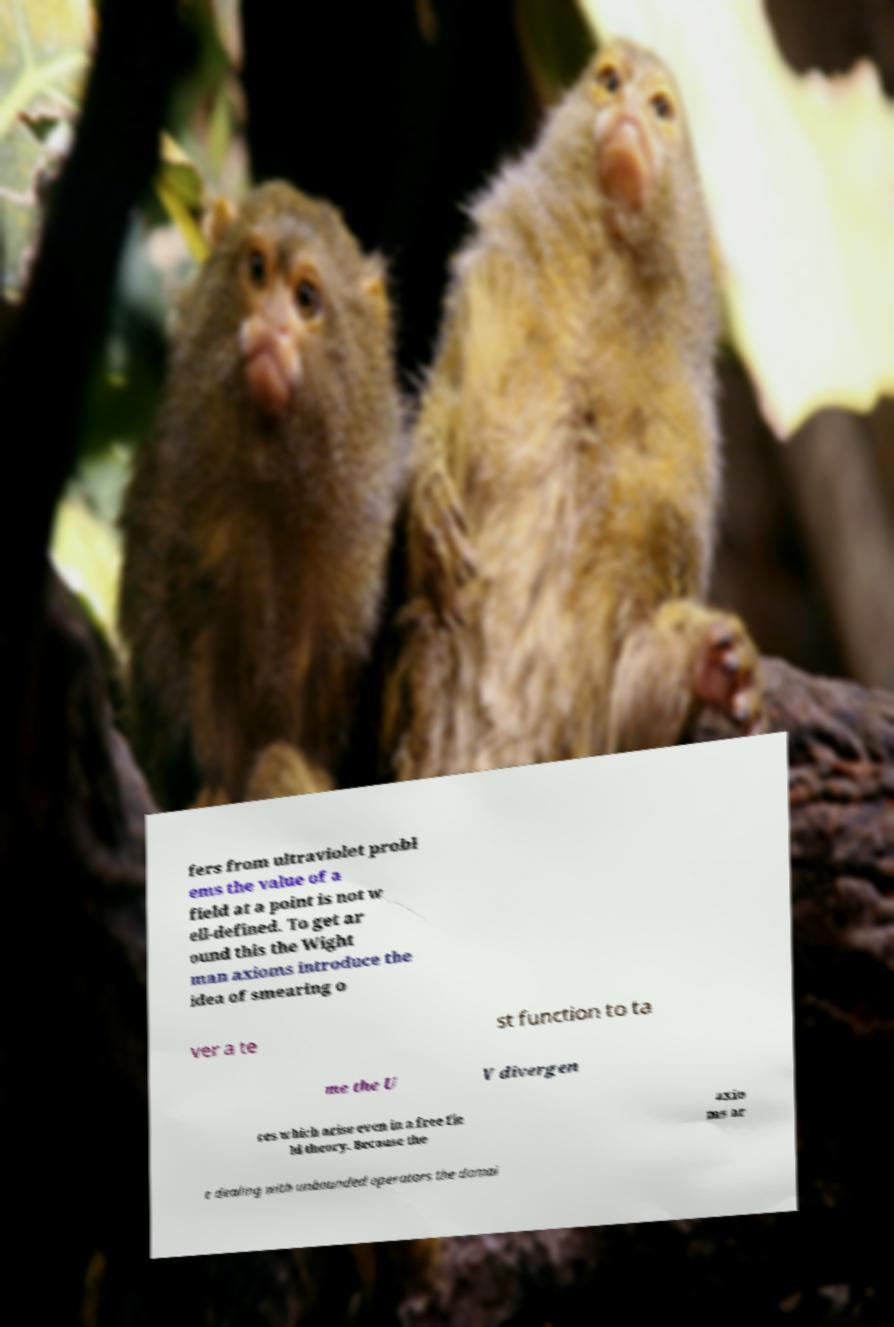There's text embedded in this image that I need extracted. Can you transcribe it verbatim? fers from ultraviolet probl ems the value of a field at a point is not w ell-defined. To get ar ound this the Wight man axioms introduce the idea of smearing o ver a te st function to ta me the U V divergen ces which arise even in a free fie ld theory. Because the axio ms ar e dealing with unbounded operators the domai 